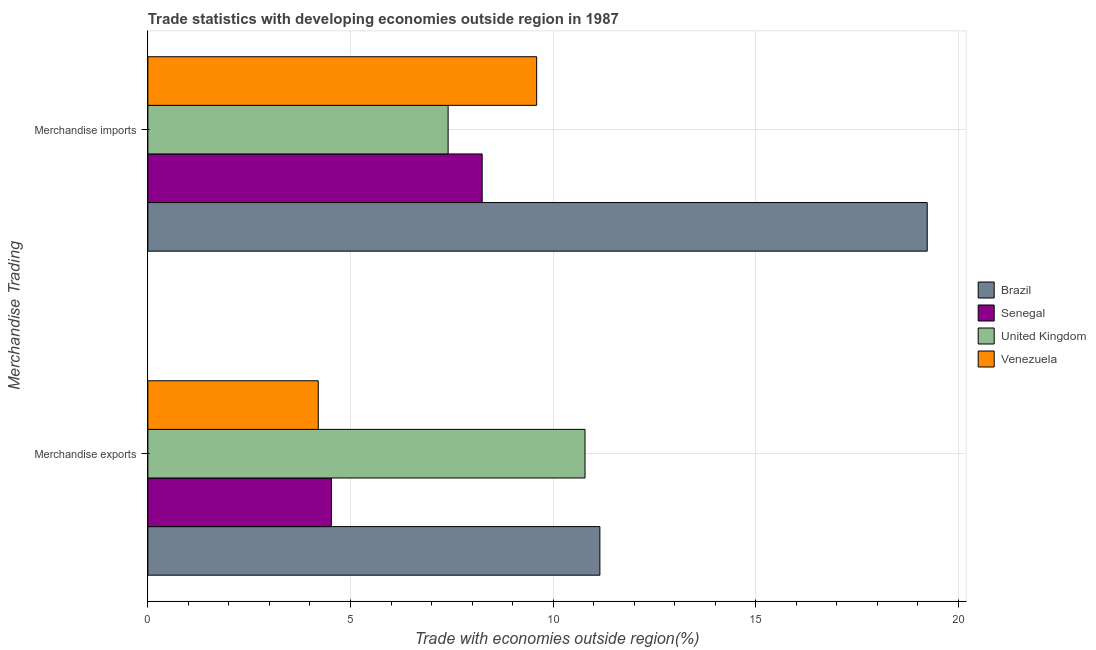How many different coloured bars are there?
Offer a terse response. 4. How many groups of bars are there?
Provide a short and direct response. 2. Are the number of bars on each tick of the Y-axis equal?
Your answer should be very brief. Yes. What is the merchandise exports in Senegal?
Make the answer very short. 4.53. Across all countries, what is the maximum merchandise imports?
Your response must be concise. 19.23. Across all countries, what is the minimum merchandise exports?
Make the answer very short. 4.21. In which country was the merchandise exports maximum?
Ensure brevity in your answer.  Brazil. In which country was the merchandise exports minimum?
Give a very brief answer. Venezuela. What is the total merchandise exports in the graph?
Keep it short and to the point. 30.68. What is the difference between the merchandise imports in Brazil and that in Senegal?
Keep it short and to the point. 10.98. What is the difference between the merchandise imports in Venezuela and the merchandise exports in Brazil?
Offer a terse response. -1.56. What is the average merchandise exports per country?
Keep it short and to the point. 7.67. What is the difference between the merchandise exports and merchandise imports in Brazil?
Your response must be concise. -8.08. In how many countries, is the merchandise exports greater than 11 %?
Give a very brief answer. 1. What is the ratio of the merchandise exports in United Kingdom to that in Brazil?
Ensure brevity in your answer.  0.97. Is the merchandise imports in Brazil less than that in Senegal?
Offer a terse response. No. What does the 3rd bar from the top in Merchandise imports represents?
Your answer should be compact. Senegal. What does the 2nd bar from the bottom in Merchandise exports represents?
Ensure brevity in your answer.  Senegal. How many bars are there?
Offer a terse response. 8. How many countries are there in the graph?
Your answer should be very brief. 4. Are the values on the major ticks of X-axis written in scientific E-notation?
Offer a very short reply. No. Does the graph contain grids?
Offer a terse response. Yes. Where does the legend appear in the graph?
Provide a short and direct response. Center right. What is the title of the graph?
Offer a very short reply. Trade statistics with developing economies outside region in 1987. Does "Australia" appear as one of the legend labels in the graph?
Offer a terse response. No. What is the label or title of the X-axis?
Give a very brief answer. Trade with economies outside region(%). What is the label or title of the Y-axis?
Offer a terse response. Merchandise Trading. What is the Trade with economies outside region(%) of Brazil in Merchandise exports?
Offer a very short reply. 11.15. What is the Trade with economies outside region(%) in Senegal in Merchandise exports?
Offer a terse response. 4.53. What is the Trade with economies outside region(%) in United Kingdom in Merchandise exports?
Provide a short and direct response. 10.79. What is the Trade with economies outside region(%) of Venezuela in Merchandise exports?
Ensure brevity in your answer.  4.21. What is the Trade with economies outside region(%) of Brazil in Merchandise imports?
Keep it short and to the point. 19.23. What is the Trade with economies outside region(%) of Senegal in Merchandise imports?
Keep it short and to the point. 8.25. What is the Trade with economies outside region(%) of United Kingdom in Merchandise imports?
Provide a succinct answer. 7.41. What is the Trade with economies outside region(%) of Venezuela in Merchandise imports?
Provide a succinct answer. 9.6. Across all Merchandise Trading, what is the maximum Trade with economies outside region(%) in Brazil?
Your response must be concise. 19.23. Across all Merchandise Trading, what is the maximum Trade with economies outside region(%) of Senegal?
Your answer should be compact. 8.25. Across all Merchandise Trading, what is the maximum Trade with economies outside region(%) of United Kingdom?
Your answer should be very brief. 10.79. Across all Merchandise Trading, what is the maximum Trade with economies outside region(%) in Venezuela?
Keep it short and to the point. 9.6. Across all Merchandise Trading, what is the minimum Trade with economies outside region(%) in Brazil?
Your response must be concise. 11.15. Across all Merchandise Trading, what is the minimum Trade with economies outside region(%) in Senegal?
Provide a succinct answer. 4.53. Across all Merchandise Trading, what is the minimum Trade with economies outside region(%) in United Kingdom?
Give a very brief answer. 7.41. Across all Merchandise Trading, what is the minimum Trade with economies outside region(%) in Venezuela?
Offer a very short reply. 4.21. What is the total Trade with economies outside region(%) of Brazil in the graph?
Ensure brevity in your answer.  30.39. What is the total Trade with economies outside region(%) in Senegal in the graph?
Offer a terse response. 12.78. What is the total Trade with economies outside region(%) of United Kingdom in the graph?
Ensure brevity in your answer.  18.2. What is the total Trade with economies outside region(%) of Venezuela in the graph?
Keep it short and to the point. 13.8. What is the difference between the Trade with economies outside region(%) in Brazil in Merchandise exports and that in Merchandise imports?
Provide a succinct answer. -8.08. What is the difference between the Trade with economies outside region(%) of Senegal in Merchandise exports and that in Merchandise imports?
Make the answer very short. -3.72. What is the difference between the Trade with economies outside region(%) in United Kingdom in Merchandise exports and that in Merchandise imports?
Provide a succinct answer. 3.38. What is the difference between the Trade with economies outside region(%) in Venezuela in Merchandise exports and that in Merchandise imports?
Ensure brevity in your answer.  -5.39. What is the difference between the Trade with economies outside region(%) in Brazil in Merchandise exports and the Trade with economies outside region(%) in Senegal in Merchandise imports?
Keep it short and to the point. 2.9. What is the difference between the Trade with economies outside region(%) of Brazil in Merchandise exports and the Trade with economies outside region(%) of United Kingdom in Merchandise imports?
Ensure brevity in your answer.  3.75. What is the difference between the Trade with economies outside region(%) of Brazil in Merchandise exports and the Trade with economies outside region(%) of Venezuela in Merchandise imports?
Your answer should be very brief. 1.56. What is the difference between the Trade with economies outside region(%) of Senegal in Merchandise exports and the Trade with economies outside region(%) of United Kingdom in Merchandise imports?
Offer a terse response. -2.88. What is the difference between the Trade with economies outside region(%) in Senegal in Merchandise exports and the Trade with economies outside region(%) in Venezuela in Merchandise imports?
Provide a succinct answer. -5.07. What is the difference between the Trade with economies outside region(%) of United Kingdom in Merchandise exports and the Trade with economies outside region(%) of Venezuela in Merchandise imports?
Offer a very short reply. 1.19. What is the average Trade with economies outside region(%) in Brazil per Merchandise Trading?
Your response must be concise. 15.19. What is the average Trade with economies outside region(%) of Senegal per Merchandise Trading?
Provide a succinct answer. 6.39. What is the average Trade with economies outside region(%) in United Kingdom per Merchandise Trading?
Offer a terse response. 9.1. What is the average Trade with economies outside region(%) of Venezuela per Merchandise Trading?
Offer a very short reply. 6.9. What is the difference between the Trade with economies outside region(%) in Brazil and Trade with economies outside region(%) in Senegal in Merchandise exports?
Offer a very short reply. 6.63. What is the difference between the Trade with economies outside region(%) in Brazil and Trade with economies outside region(%) in United Kingdom in Merchandise exports?
Your answer should be very brief. 0.37. What is the difference between the Trade with economies outside region(%) of Brazil and Trade with economies outside region(%) of Venezuela in Merchandise exports?
Offer a terse response. 6.95. What is the difference between the Trade with economies outside region(%) in Senegal and Trade with economies outside region(%) in United Kingdom in Merchandise exports?
Offer a terse response. -6.26. What is the difference between the Trade with economies outside region(%) of Senegal and Trade with economies outside region(%) of Venezuela in Merchandise exports?
Keep it short and to the point. 0.32. What is the difference between the Trade with economies outside region(%) of United Kingdom and Trade with economies outside region(%) of Venezuela in Merchandise exports?
Offer a very short reply. 6.58. What is the difference between the Trade with economies outside region(%) of Brazil and Trade with economies outside region(%) of Senegal in Merchandise imports?
Your answer should be compact. 10.98. What is the difference between the Trade with economies outside region(%) in Brazil and Trade with economies outside region(%) in United Kingdom in Merchandise imports?
Offer a terse response. 11.82. What is the difference between the Trade with economies outside region(%) in Brazil and Trade with economies outside region(%) in Venezuela in Merchandise imports?
Offer a very short reply. 9.64. What is the difference between the Trade with economies outside region(%) in Senegal and Trade with economies outside region(%) in United Kingdom in Merchandise imports?
Your answer should be compact. 0.84. What is the difference between the Trade with economies outside region(%) in Senegal and Trade with economies outside region(%) in Venezuela in Merchandise imports?
Your response must be concise. -1.34. What is the difference between the Trade with economies outside region(%) of United Kingdom and Trade with economies outside region(%) of Venezuela in Merchandise imports?
Give a very brief answer. -2.19. What is the ratio of the Trade with economies outside region(%) in Brazil in Merchandise exports to that in Merchandise imports?
Ensure brevity in your answer.  0.58. What is the ratio of the Trade with economies outside region(%) of Senegal in Merchandise exports to that in Merchandise imports?
Ensure brevity in your answer.  0.55. What is the ratio of the Trade with economies outside region(%) of United Kingdom in Merchandise exports to that in Merchandise imports?
Offer a very short reply. 1.46. What is the ratio of the Trade with economies outside region(%) in Venezuela in Merchandise exports to that in Merchandise imports?
Your response must be concise. 0.44. What is the difference between the highest and the second highest Trade with economies outside region(%) of Brazil?
Ensure brevity in your answer.  8.08. What is the difference between the highest and the second highest Trade with economies outside region(%) in Senegal?
Keep it short and to the point. 3.72. What is the difference between the highest and the second highest Trade with economies outside region(%) of United Kingdom?
Make the answer very short. 3.38. What is the difference between the highest and the second highest Trade with economies outside region(%) in Venezuela?
Provide a short and direct response. 5.39. What is the difference between the highest and the lowest Trade with economies outside region(%) of Brazil?
Your response must be concise. 8.08. What is the difference between the highest and the lowest Trade with economies outside region(%) of Senegal?
Your answer should be very brief. 3.72. What is the difference between the highest and the lowest Trade with economies outside region(%) in United Kingdom?
Provide a succinct answer. 3.38. What is the difference between the highest and the lowest Trade with economies outside region(%) of Venezuela?
Ensure brevity in your answer.  5.39. 